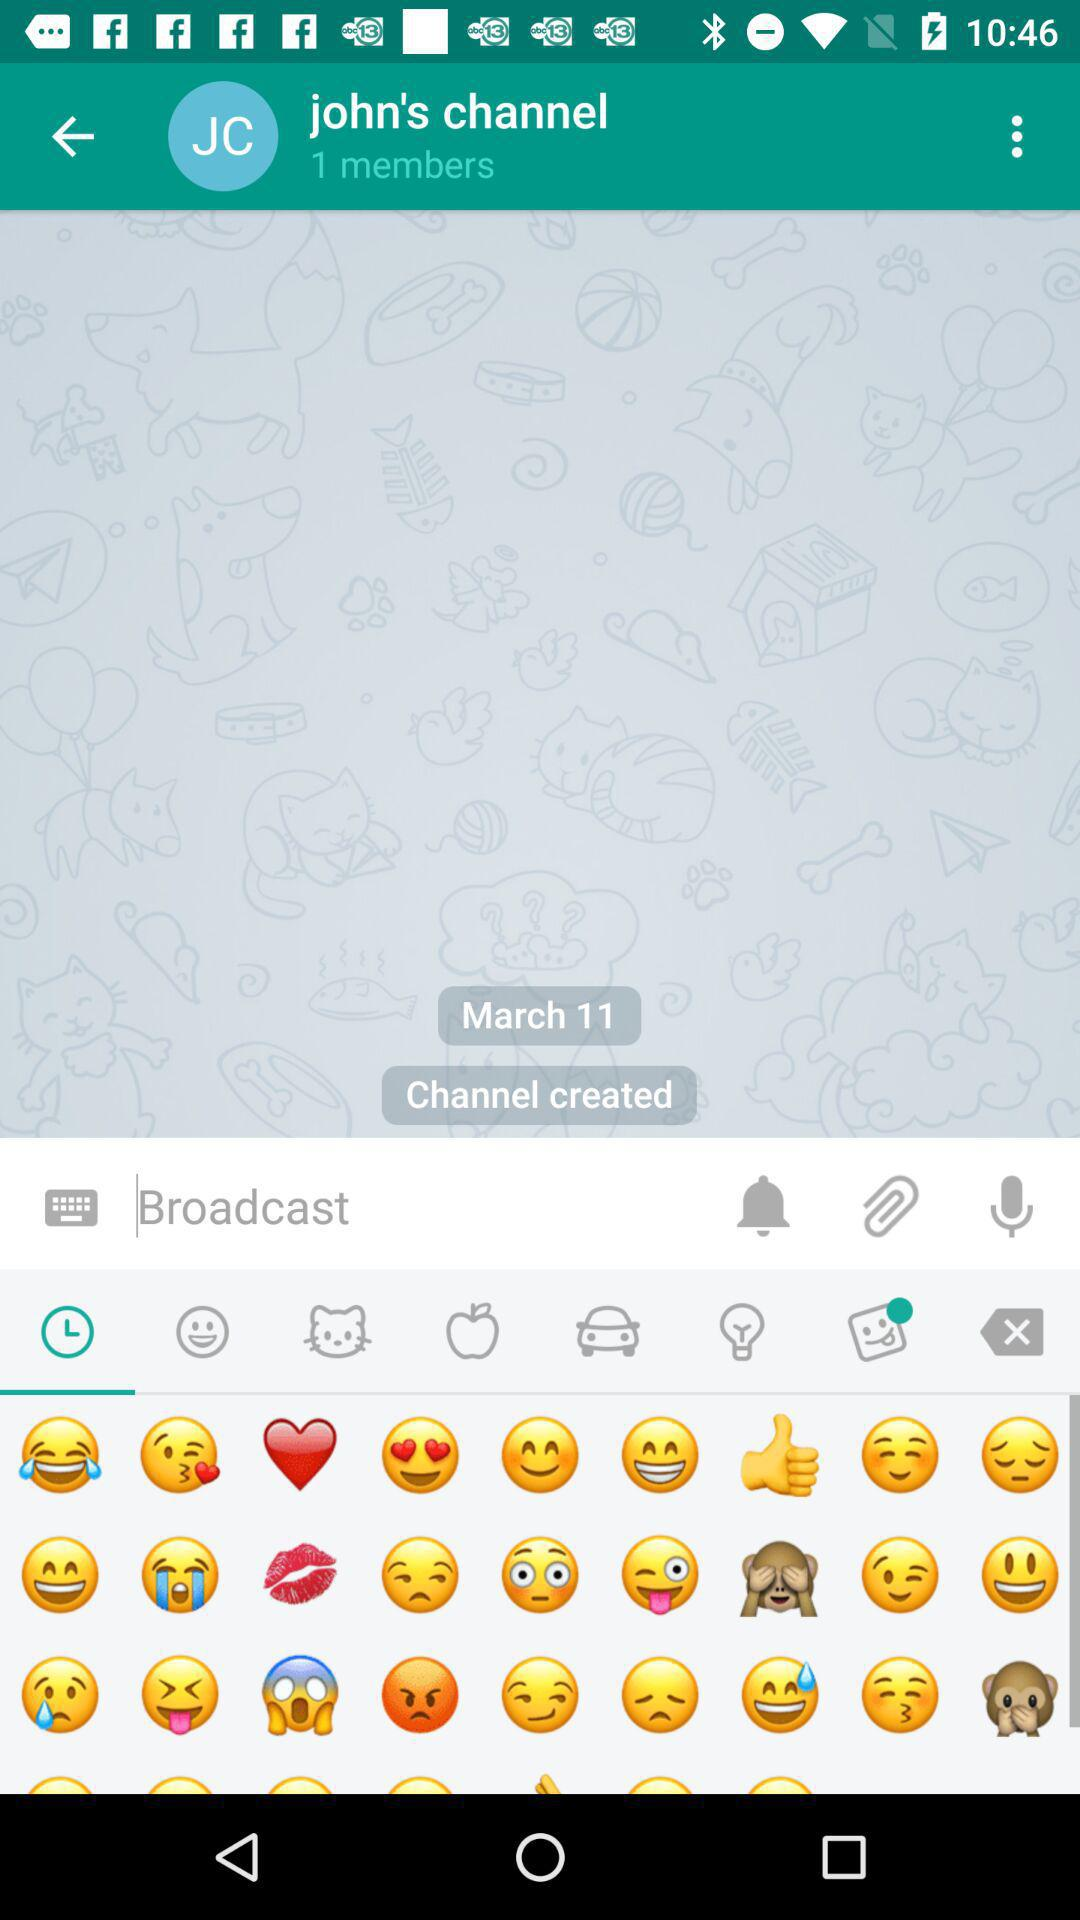How many emojis are there with a tear coming out of their eye?
Answer the question using a single word or phrase. 2 